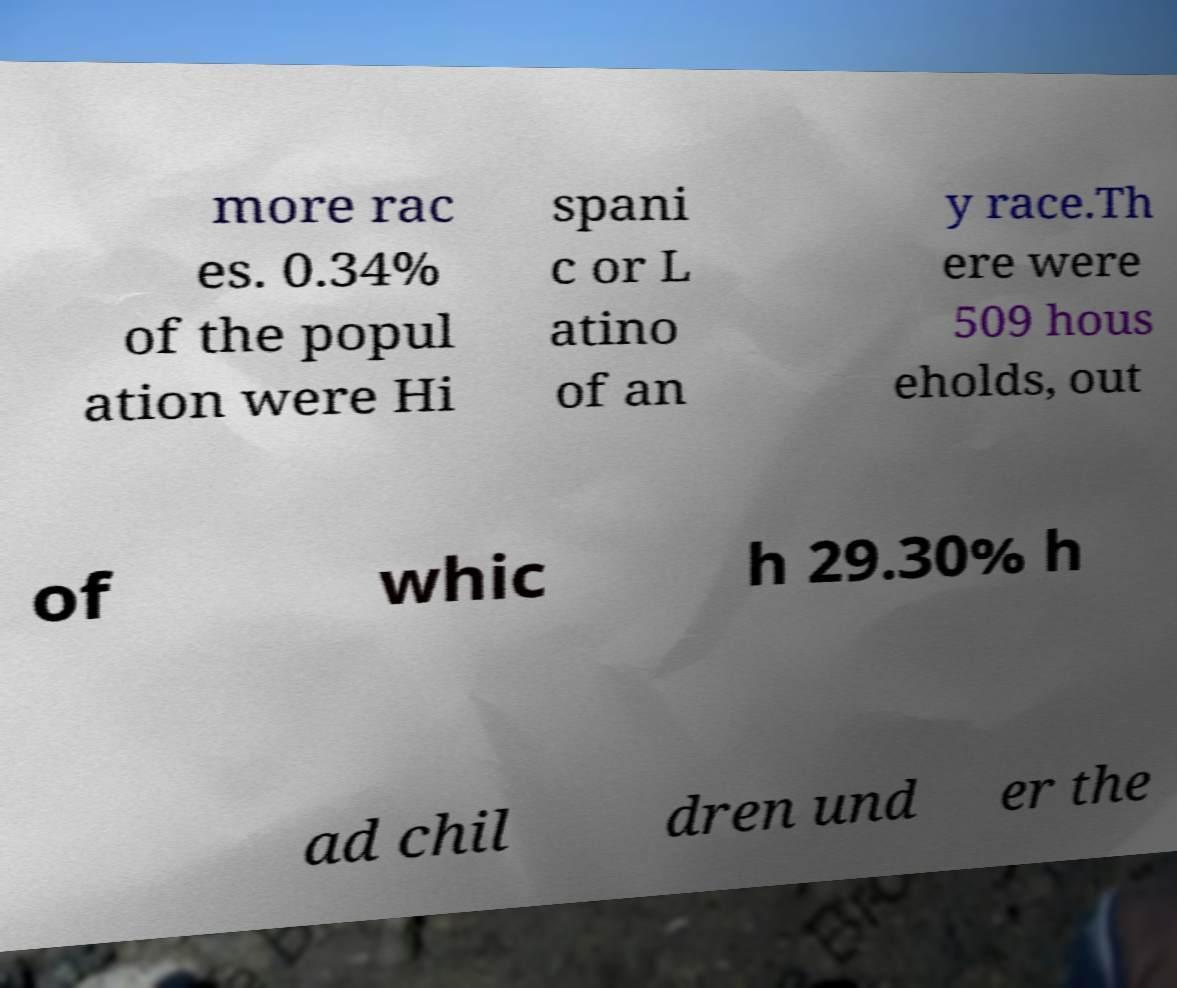Can you read and provide the text displayed in the image?This photo seems to have some interesting text. Can you extract and type it out for me? more rac es. 0.34% of the popul ation were Hi spani c or L atino of an y race.Th ere were 509 hous eholds, out of whic h 29.30% h ad chil dren und er the 